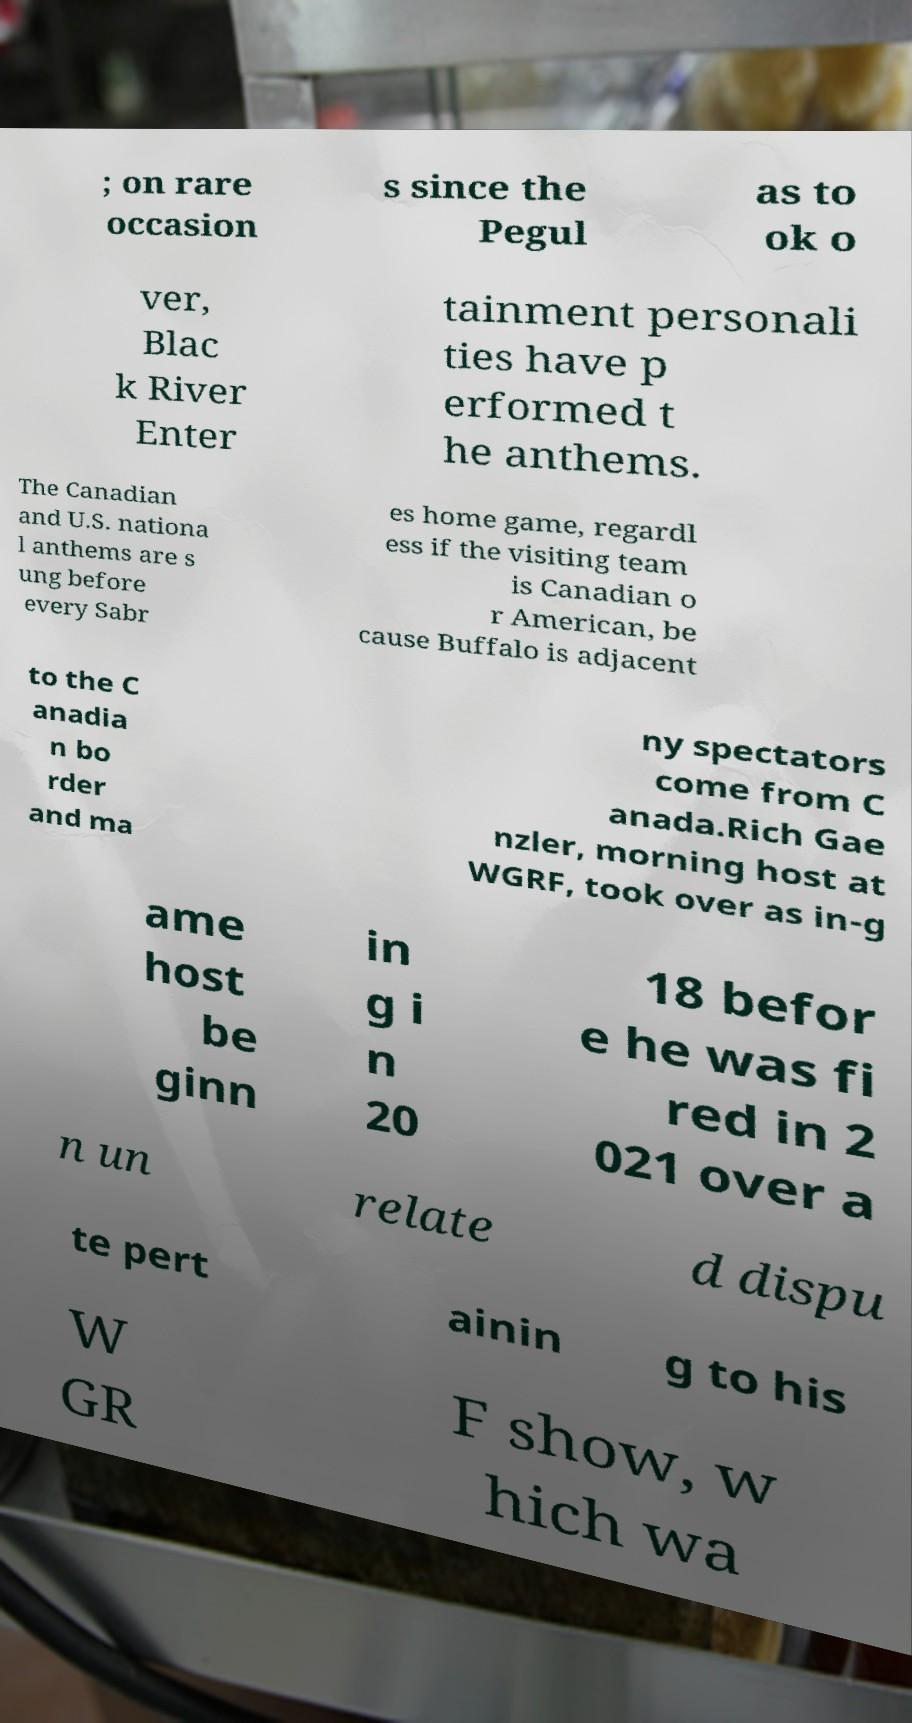For documentation purposes, I need the text within this image transcribed. Could you provide that? ; on rare occasion s since the Pegul as to ok o ver, Blac k River Enter tainment personali ties have p erformed t he anthems. The Canadian and U.S. nationa l anthems are s ung before every Sabr es home game, regardl ess if the visiting team is Canadian o r American, be cause Buffalo is adjacent to the C anadia n bo rder and ma ny spectators come from C anada.Rich Gae nzler, morning host at WGRF, took over as in-g ame host be ginn in g i n 20 18 befor e he was fi red in 2 021 over a n un relate d dispu te pert ainin g to his W GR F show, w hich wa 